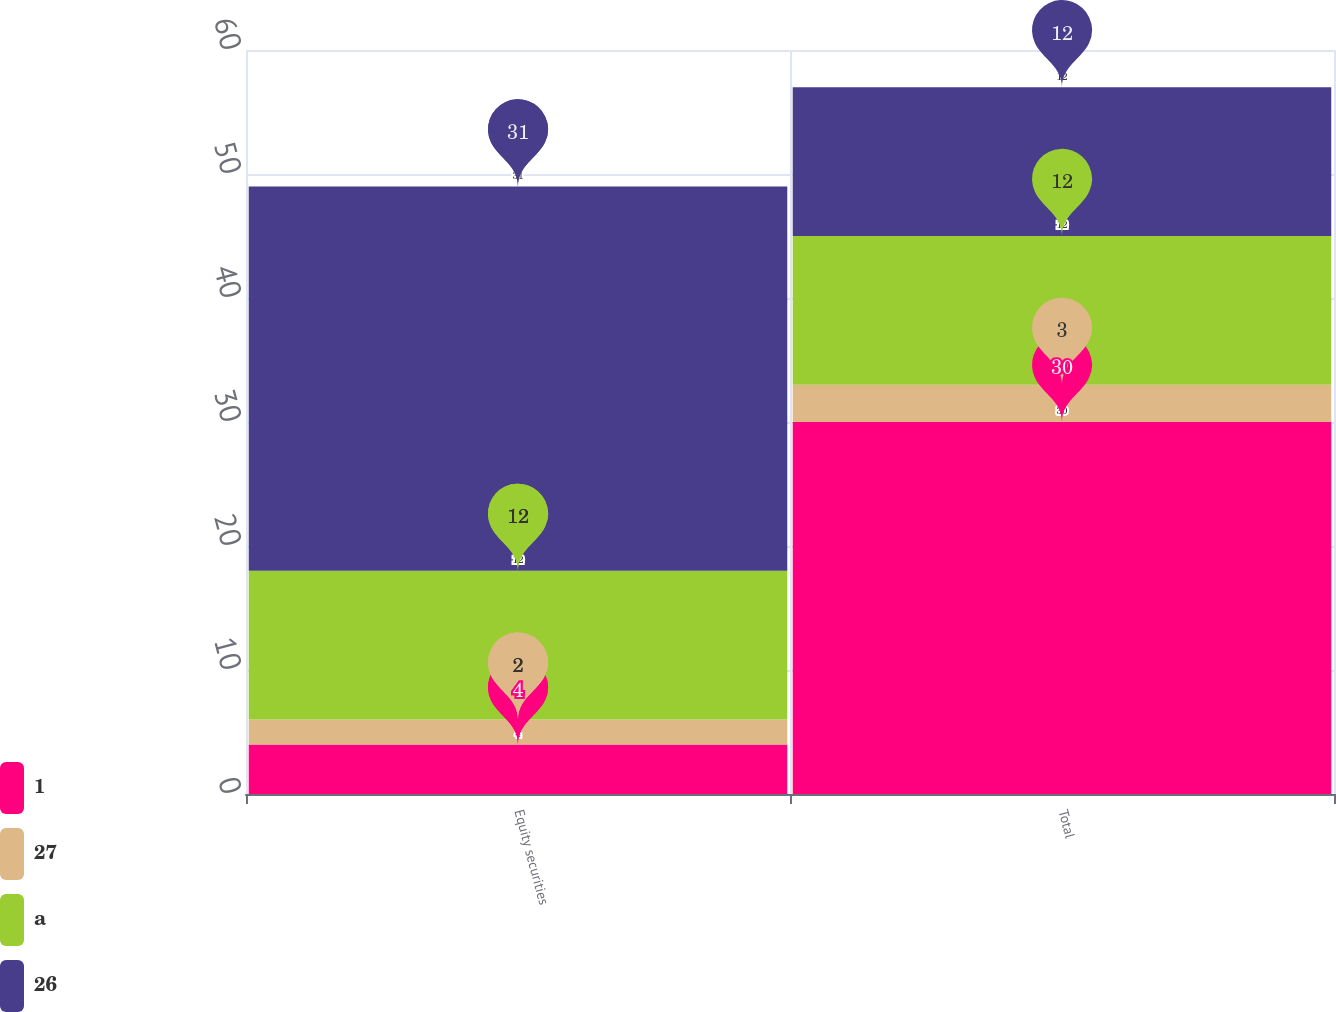<chart> <loc_0><loc_0><loc_500><loc_500><stacked_bar_chart><ecel><fcel>Equity securities<fcel>Total<nl><fcel>1<fcel>4<fcel>30<nl><fcel>27<fcel>2<fcel>3<nl><fcel>a<fcel>12<fcel>12<nl><fcel>26<fcel>31<fcel>12<nl></chart> 